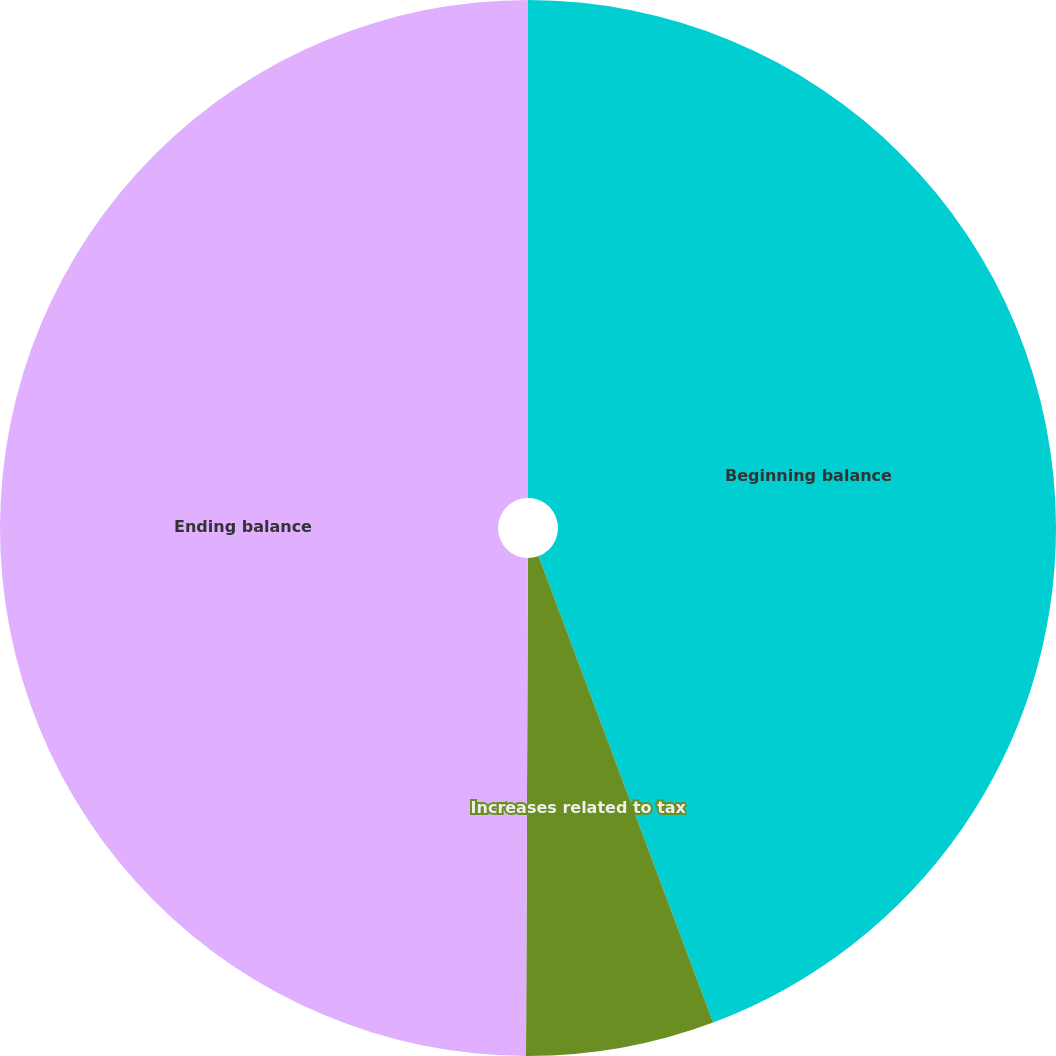Convert chart. <chart><loc_0><loc_0><loc_500><loc_500><pie_chart><fcel>Beginning balance<fcel>Increases related to tax<fcel>Ending balance<nl><fcel>44.3%<fcel>5.76%<fcel>49.94%<nl></chart> 